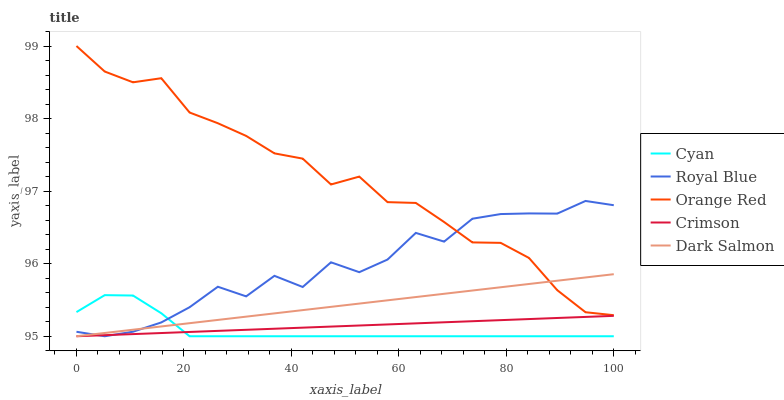Does Cyan have the minimum area under the curve?
Answer yes or no. Yes. Does Orange Red have the maximum area under the curve?
Answer yes or no. Yes. Does Dark Salmon have the minimum area under the curve?
Answer yes or no. No. Does Dark Salmon have the maximum area under the curve?
Answer yes or no. No. Is Dark Salmon the smoothest?
Answer yes or no. Yes. Is Royal Blue the roughest?
Answer yes or no. Yes. Is Cyan the smoothest?
Answer yes or no. No. Is Cyan the roughest?
Answer yes or no. No. Does Crimson have the lowest value?
Answer yes or no. Yes. Does Orange Red have the lowest value?
Answer yes or no. No. Does Orange Red have the highest value?
Answer yes or no. Yes. Does Cyan have the highest value?
Answer yes or no. No. Is Crimson less than Orange Red?
Answer yes or no. Yes. Is Orange Red greater than Cyan?
Answer yes or no. Yes. Does Cyan intersect Dark Salmon?
Answer yes or no. Yes. Is Cyan less than Dark Salmon?
Answer yes or no. No. Is Cyan greater than Dark Salmon?
Answer yes or no. No. Does Crimson intersect Orange Red?
Answer yes or no. No. 